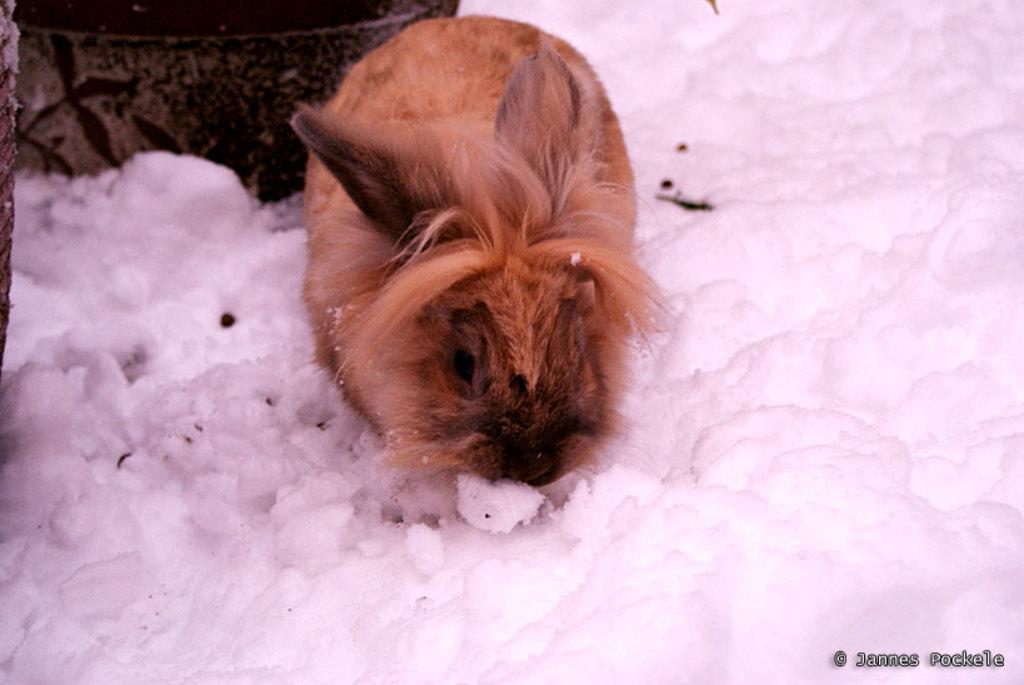Can you describe this image briefly? In this picture there is a rabbit in the center of the image and there is snow around the area of the image. 